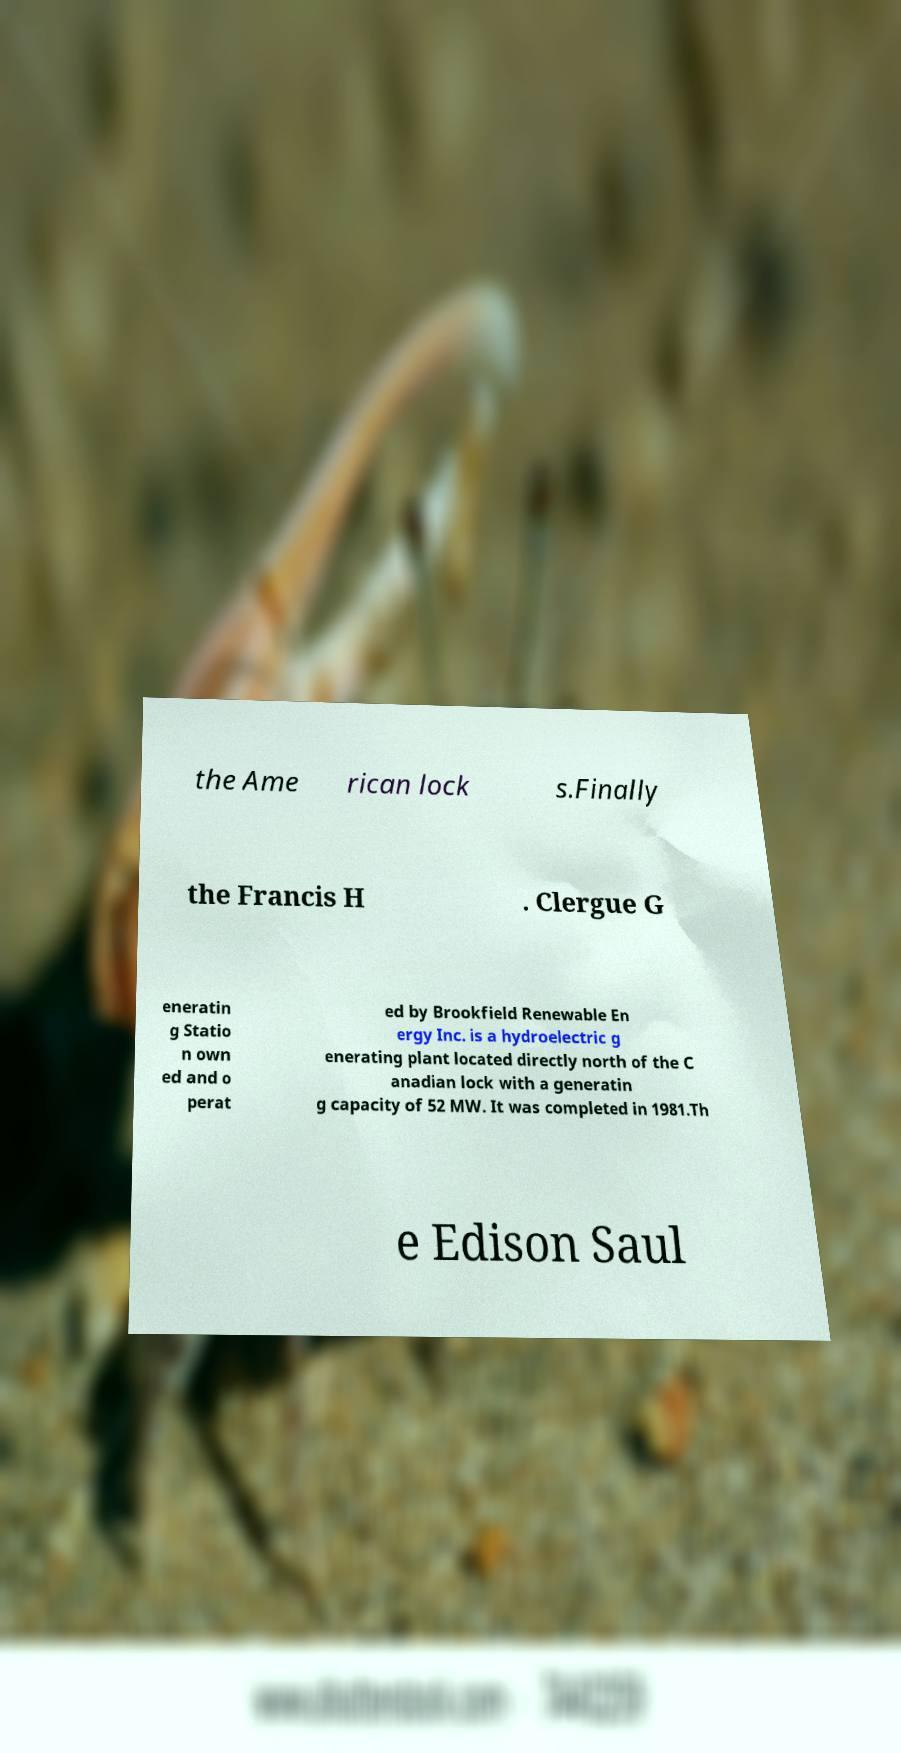Please identify and transcribe the text found in this image. the Ame rican lock s.Finally the Francis H . Clergue G eneratin g Statio n own ed and o perat ed by Brookfield Renewable En ergy Inc. is a hydroelectric g enerating plant located directly north of the C anadian lock with a generatin g capacity of 52 MW. It was completed in 1981.Th e Edison Saul 